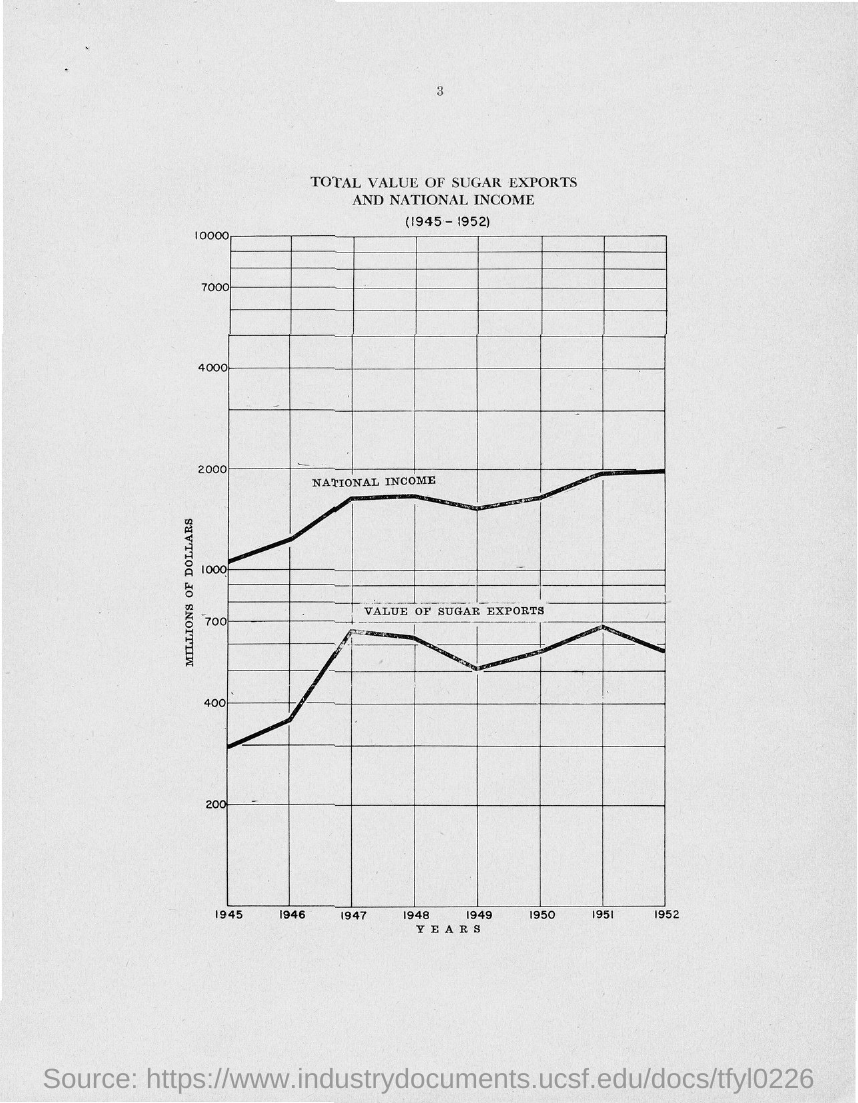What is plotted in the y-axis?
Give a very brief answer. Millions of Dollars. What is plotted in the x-axis ?
Ensure brevity in your answer.  Years. 